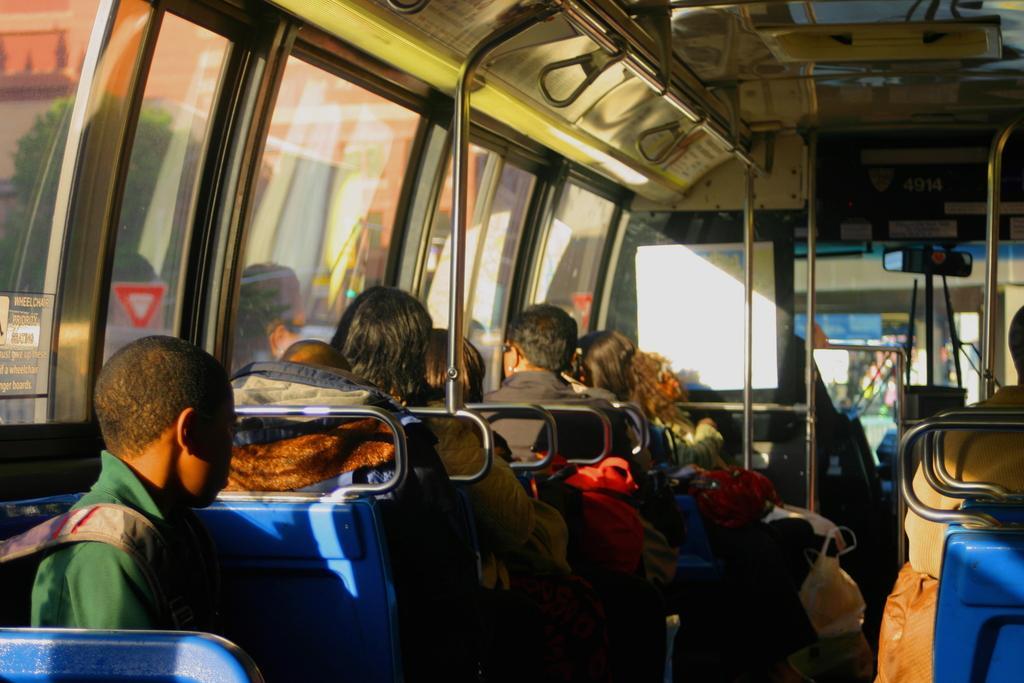Please provide a concise description of this image. In this image there are people sitting in a bus. 